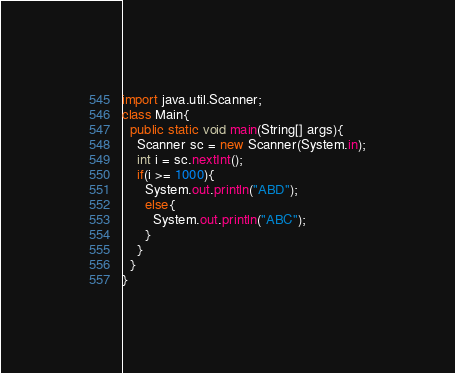<code> <loc_0><loc_0><loc_500><loc_500><_Java_>import java.util.Scanner;
class Main{
  public static void main(String[] args){
    Scanner sc = new Scanner(System.in);
    int i = sc.nextInt();
    if(i >= 1000){
      System.out.println("ABD");
      else{
        System.out.println("ABC");
      }
    }
  }
}</code> 